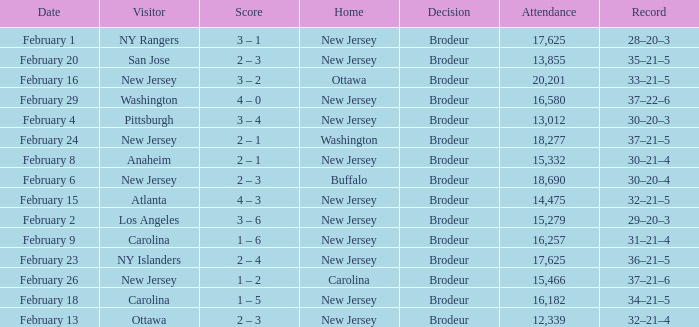What was the score when the NY Islanders was the visiting team? 2 – 4. 